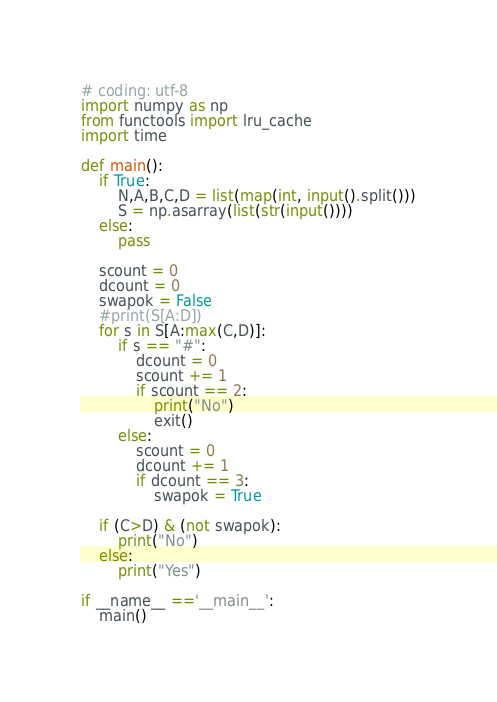<code> <loc_0><loc_0><loc_500><loc_500><_Python_># coding: utf-8
import numpy as np
from functools import lru_cache
import time

def main(): 
    if True:
        N,A,B,C,D = list(map(int, input().split()))
        S = np.asarray(list(str(input())))
    else:
        pass

    scount = 0
    dcount = 0
    swapok = False
    #print(S[A:D])
    for s in S[A:max(C,D)]:
        if s == "#":
            dcount = 0
            scount += 1
            if scount == 2:
                print("No")
                exit()
        else:
            scount = 0
            dcount += 1
            if dcount == 3:
                swapok = True
    
    if (C>D) & (not swapok):
        print("No")
    else:
        print("Yes")

if __name__ =='__main__':
    main()</code> 